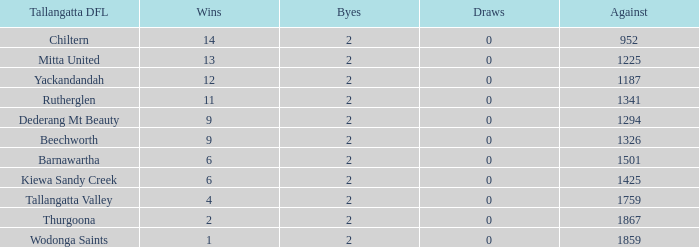What are the draws when wins are fwewer than 9 and byes fewer than 2? 0.0. 